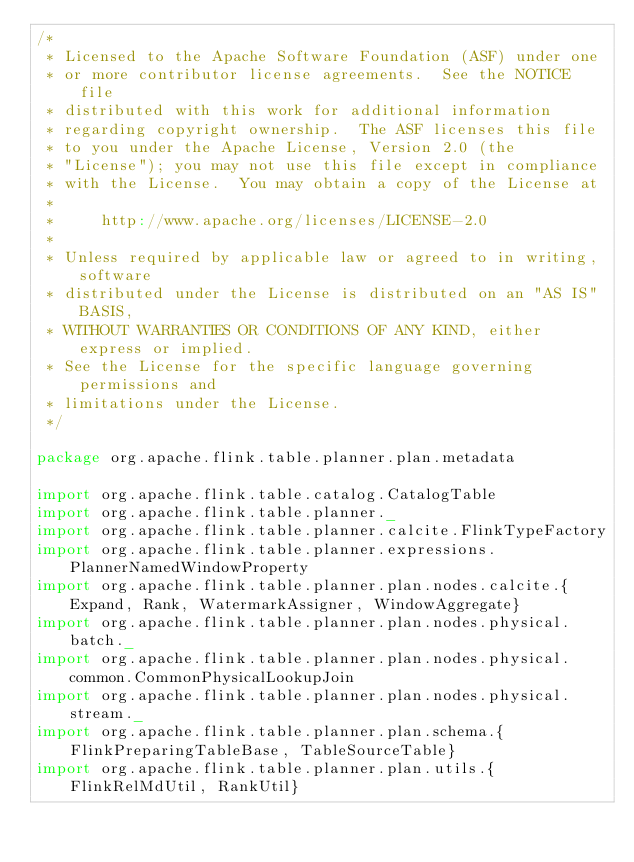<code> <loc_0><loc_0><loc_500><loc_500><_Scala_>/*
 * Licensed to the Apache Software Foundation (ASF) under one
 * or more contributor license agreements.  See the NOTICE file
 * distributed with this work for additional information
 * regarding copyright ownership.  The ASF licenses this file
 * to you under the Apache License, Version 2.0 (the
 * "License"); you may not use this file except in compliance
 * with the License.  You may obtain a copy of the License at
 *
 *     http://www.apache.org/licenses/LICENSE-2.0
 *
 * Unless required by applicable law or agreed to in writing, software
 * distributed under the License is distributed on an "AS IS" BASIS,
 * WITHOUT WARRANTIES OR CONDITIONS OF ANY KIND, either express or implied.
 * See the License for the specific language governing permissions and
 * limitations under the License.
 */

package org.apache.flink.table.planner.plan.metadata

import org.apache.flink.table.catalog.CatalogTable
import org.apache.flink.table.planner._
import org.apache.flink.table.planner.calcite.FlinkTypeFactory
import org.apache.flink.table.planner.expressions.PlannerNamedWindowProperty
import org.apache.flink.table.planner.plan.nodes.calcite.{Expand, Rank, WatermarkAssigner, WindowAggregate}
import org.apache.flink.table.planner.plan.nodes.physical.batch._
import org.apache.flink.table.planner.plan.nodes.physical.common.CommonPhysicalLookupJoin
import org.apache.flink.table.planner.plan.nodes.physical.stream._
import org.apache.flink.table.planner.plan.schema.{FlinkPreparingTableBase, TableSourceTable}
import org.apache.flink.table.planner.plan.utils.{FlinkRelMdUtil, RankUtil}</code> 